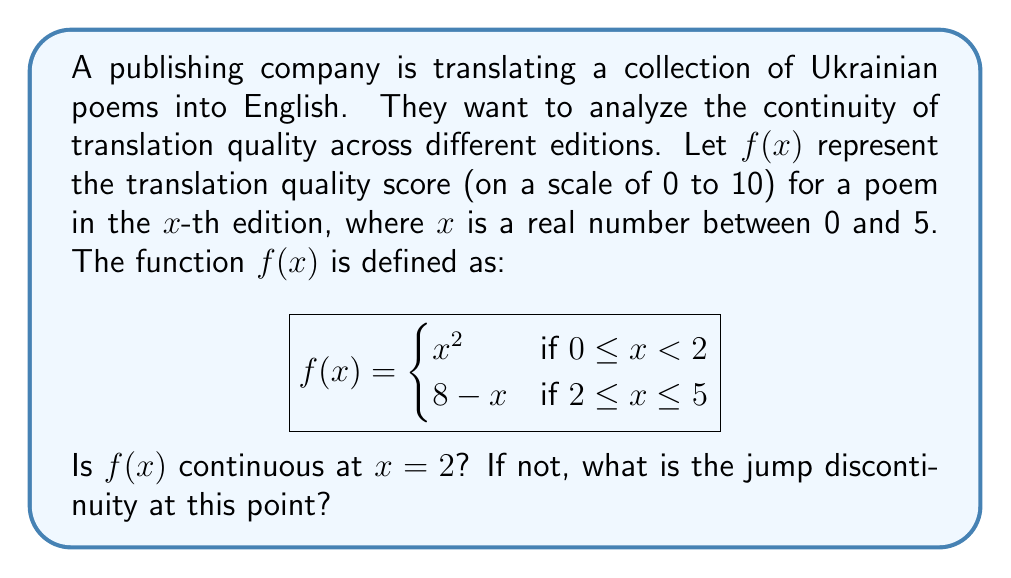Give your solution to this math problem. To determine if $f(x)$ is continuous at $x = 2$, we need to check three conditions:

1. $f(x)$ is defined at $x = 2$
2. $\lim_{x \to 2^-} f(x)$ exists
3. $\lim_{x \to 2^+} f(x)$ exists
4. $\lim_{x \to 2^-} f(x) = \lim_{x \to 2^+} f(x) = f(2)$

Let's check each condition:

1. $f(2)$ is defined: $f(2) = 8 - 2 = 6$

2. $\lim_{x \to 2^-} f(x) = \lim_{x \to 2^-} x^2 = 2^2 = 4$

3. $\lim_{x \to 2^+} f(x) = \lim_{x \to 2^+} (8 - x) = 8 - 2 = 6$

4. We can see that $\lim_{x \to 2^-} f(x) \neq \lim_{x \to 2^+} f(x)$

Since the left-hand limit does not equal the right-hand limit, $f(x)$ is not continuous at $x = 2$.

To find the jump discontinuity, we calculate the difference between the right-hand limit and the left-hand limit:

Jump discontinuity = $\lim_{x \to 2^+} f(x) - \lim_{x \to 2^-} f(x) = 6 - 4 = 2$
Answer: $f(x)$ is not continuous at $x = 2$. The jump discontinuity at this point is 2. 